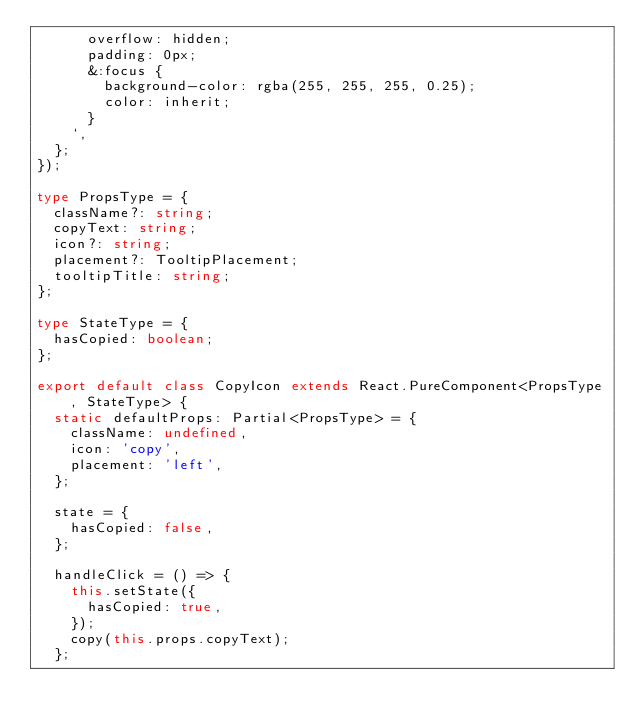Convert code to text. <code><loc_0><loc_0><loc_500><loc_500><_TypeScript_>      overflow: hidden;
      padding: 0px;
      &:focus {
        background-color: rgba(255, 255, 255, 0.25);
        color: inherit;
      }
    `,
  };
});

type PropsType = {
  className?: string;
  copyText: string;
  icon?: string;
  placement?: TooltipPlacement;
  tooltipTitle: string;
};

type StateType = {
  hasCopied: boolean;
};

export default class CopyIcon extends React.PureComponent<PropsType, StateType> {
  static defaultProps: Partial<PropsType> = {
    className: undefined,
    icon: 'copy',
    placement: 'left',
  };

  state = {
    hasCopied: false,
  };

  handleClick = () => {
    this.setState({
      hasCopied: true,
    });
    copy(this.props.copyText);
  };
</code> 